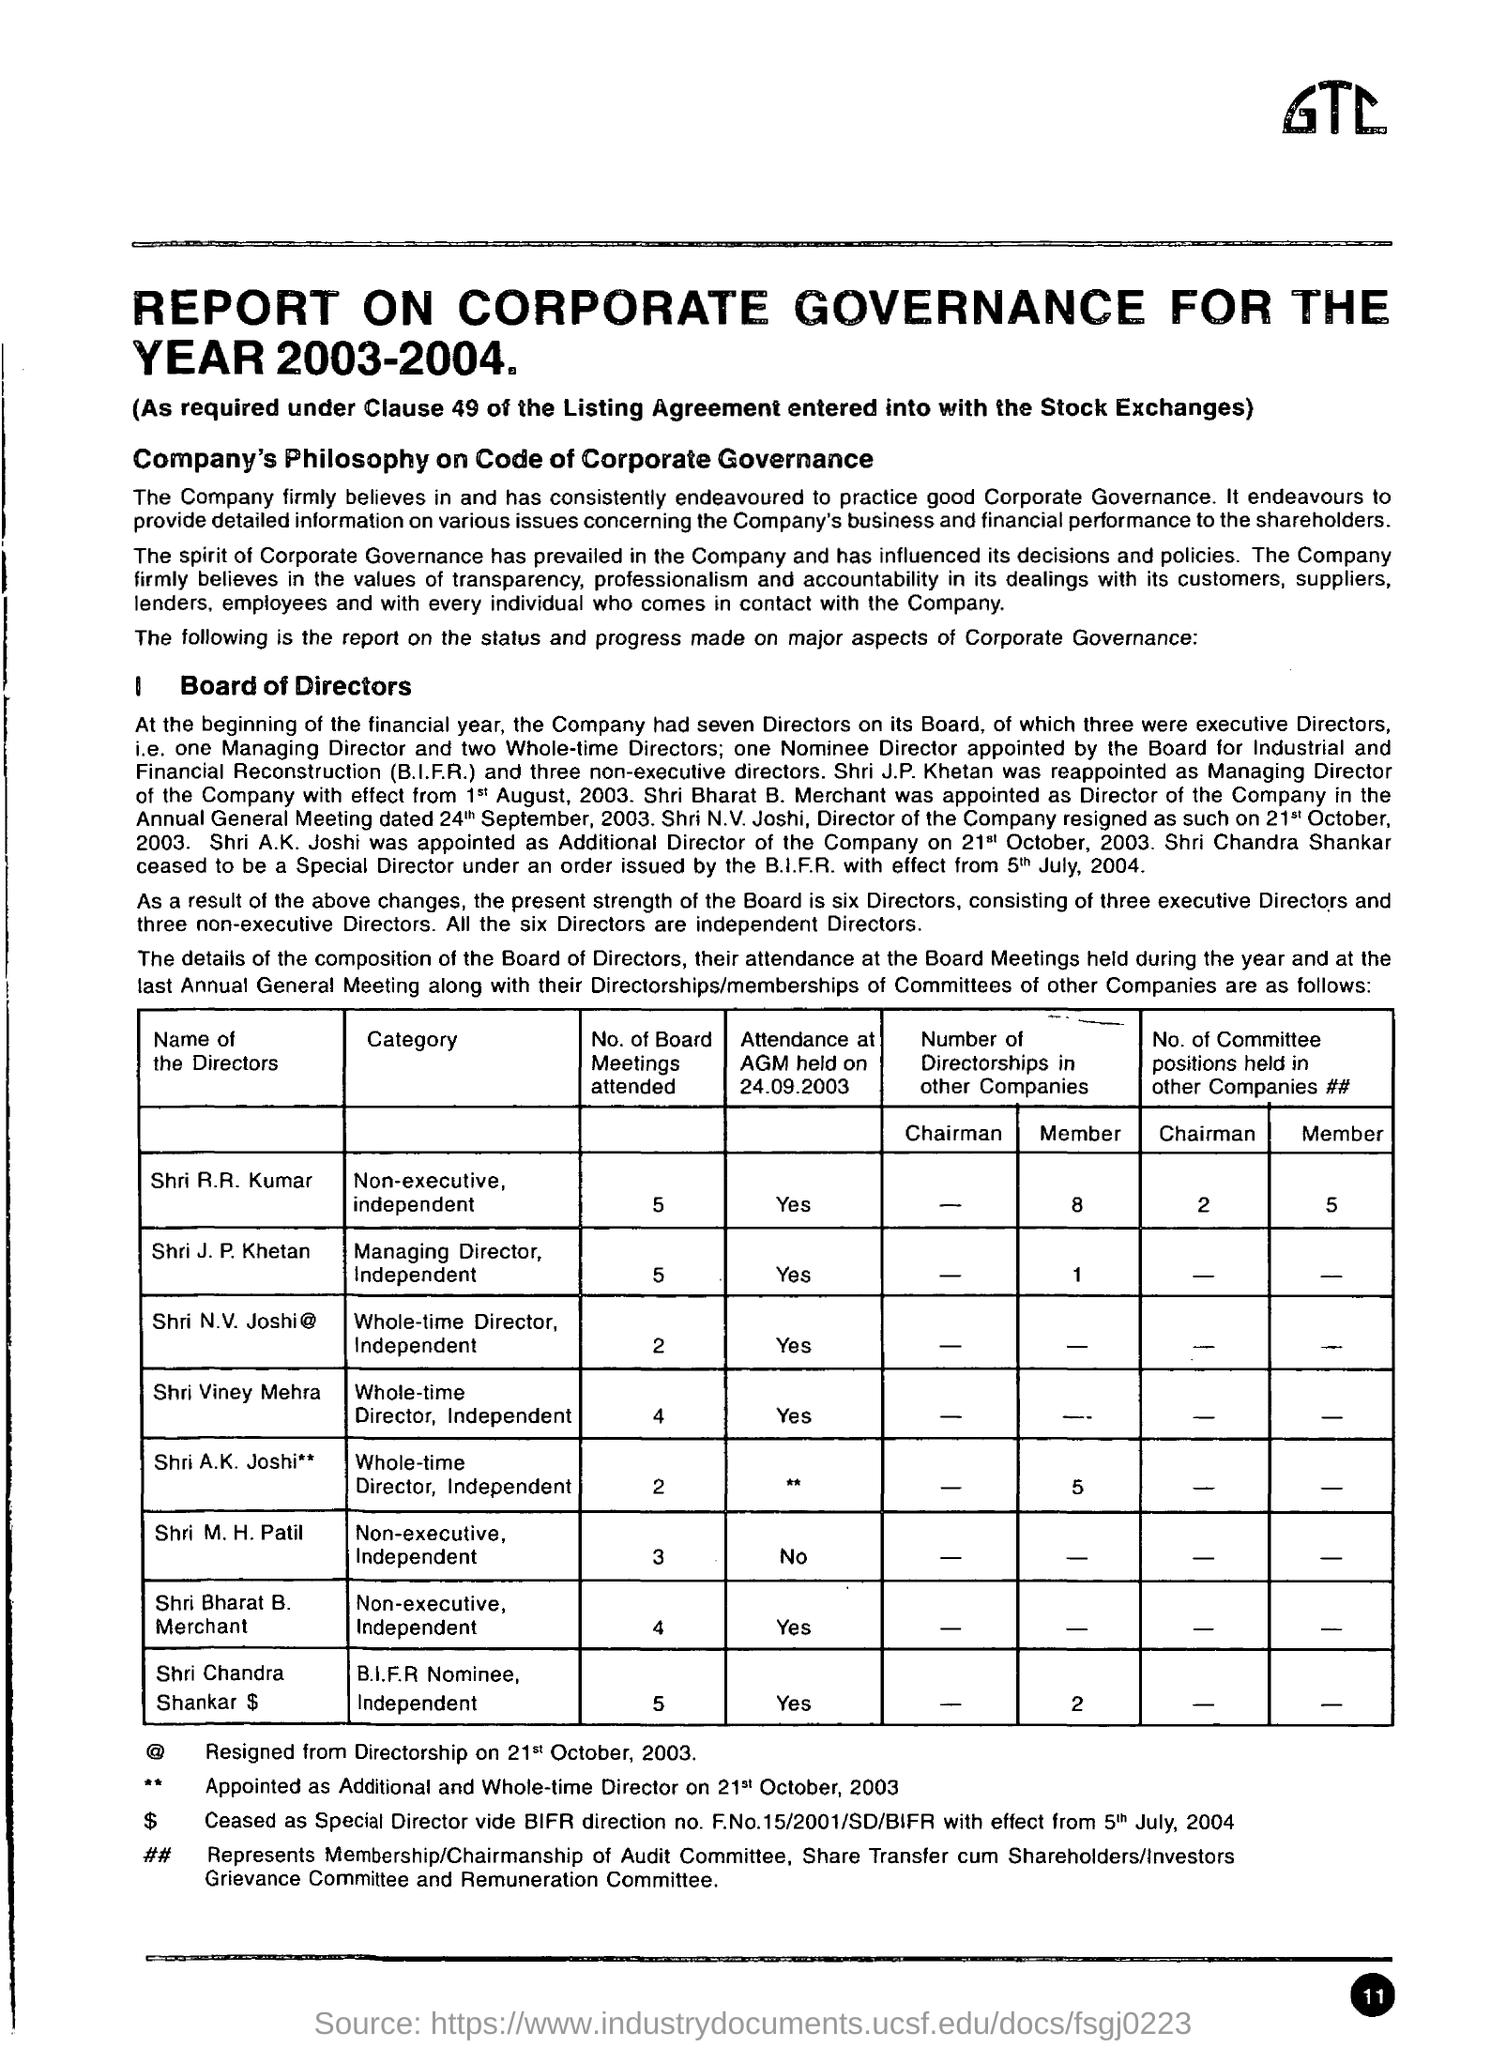At the beginning of the financial year  how many directors company had
Give a very brief answer. Seven directors. How many no of Board meeting are attended by Director Shri R.R Kumar
Your answer should be compact. 5. 